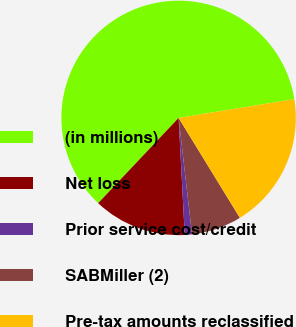<chart> <loc_0><loc_0><loc_500><loc_500><pie_chart><fcel>(in millions)<fcel>Net loss<fcel>Prior service cost/credit<fcel>SABMiller (2)<fcel>Pre-tax amounts reclassified<nl><fcel>60.4%<fcel>12.87%<fcel>0.99%<fcel>6.93%<fcel>18.81%<nl></chart> 